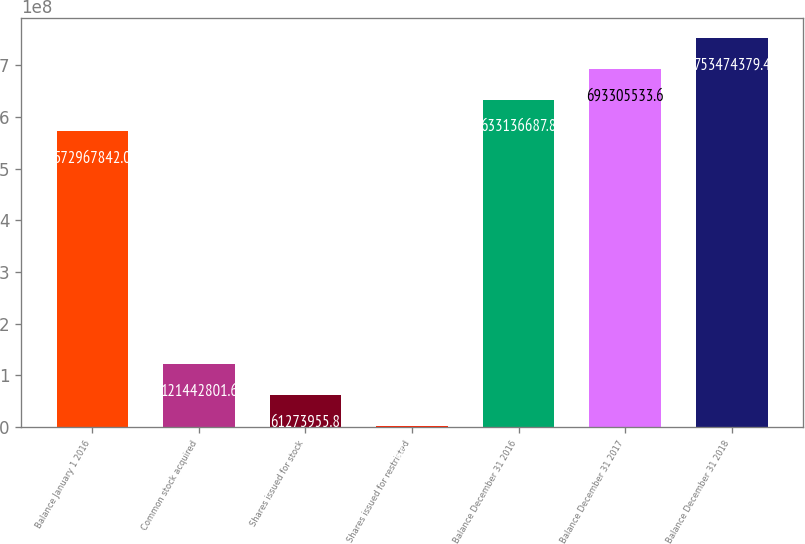Convert chart. <chart><loc_0><loc_0><loc_500><loc_500><bar_chart><fcel>Balance January 1 2016<fcel>Common stock acquired<fcel>Shares issued for stock<fcel>Shares issued for restricted<fcel>Balance December 31 2016<fcel>Balance December 31 2017<fcel>Balance December 31 2018<nl><fcel>5.72968e+08<fcel>1.21443e+08<fcel>6.1274e+07<fcel>1.10511e+06<fcel>6.33137e+08<fcel>6.93306e+08<fcel>7.53474e+08<nl></chart> 